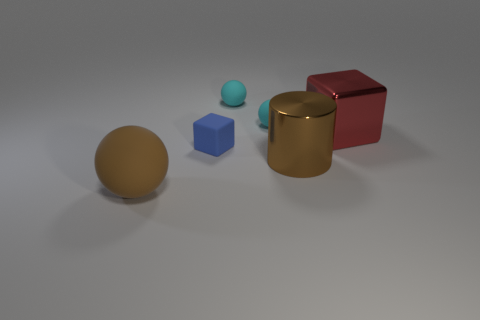Is there any other thing that has the same shape as the brown metallic object?
Make the answer very short. No. Is there a red cube?
Provide a short and direct response. Yes. The matte sphere that is on the left side of the rubber block is what color?
Your answer should be compact. Brown. What material is the cylinder that is the same size as the red shiny thing?
Give a very brief answer. Metal. How many other objects are the same material as the red cube?
Give a very brief answer. 1. There is a big object that is on the right side of the large brown rubber object and left of the large metallic cube; what is its color?
Provide a short and direct response. Brown. What number of things are balls that are behind the big brown metal object or small rubber balls?
Offer a very short reply. 2. How many other objects are there of the same color as the large cylinder?
Ensure brevity in your answer.  1. Are there an equal number of big red shiny cubes right of the red thing and blue matte objects?
Your response must be concise. No. How many small rubber things are to the left of the big brown thing to the right of the tiny matte object in front of the metallic block?
Your answer should be very brief. 3. 